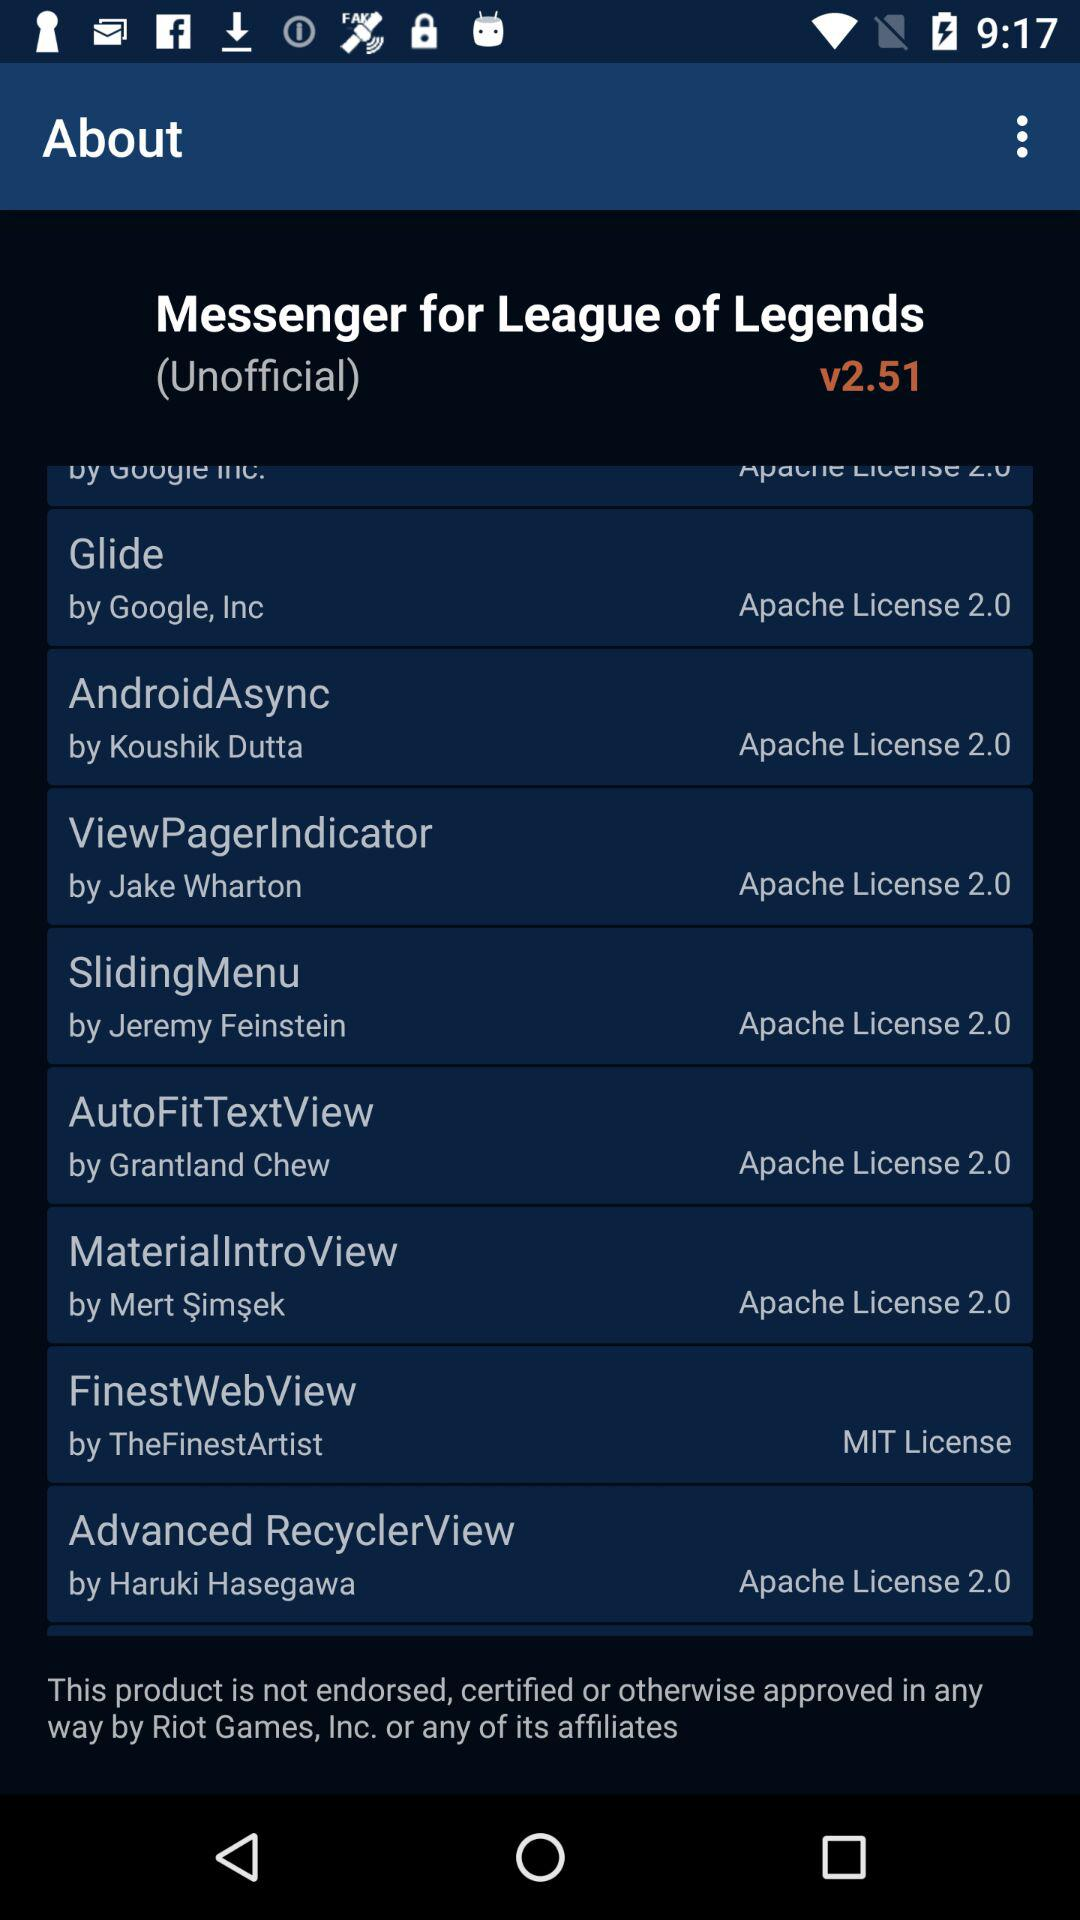Jeremy Feinstein introduced which app? Jeremy Feinstein introduced "SlidingMenu". 